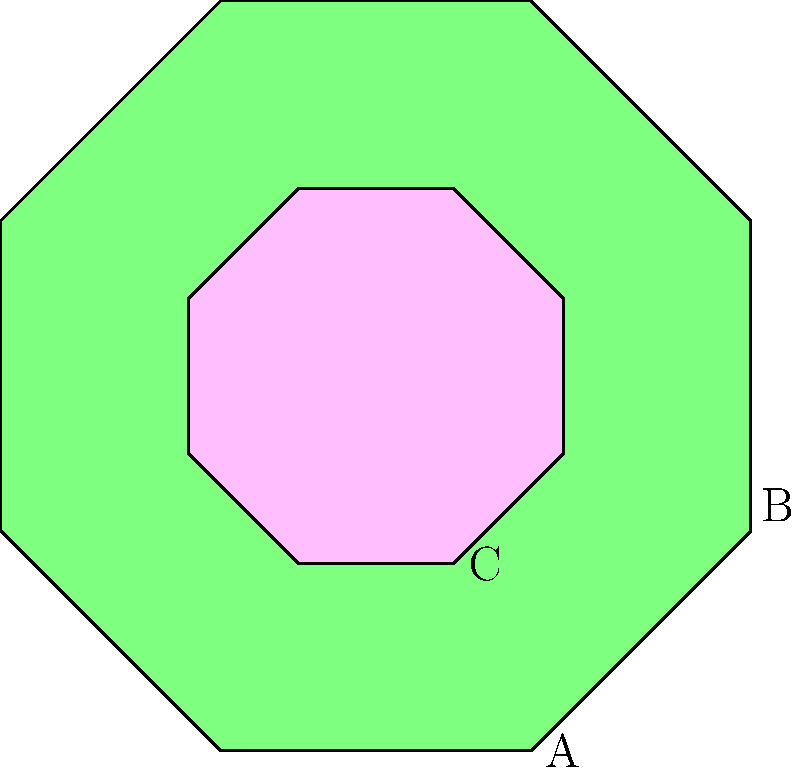In traditional Latvian folk art, geometric patterns often feature prominently. The diagram shows three regular octagons A, B, and C. Which of these octagons are congruent to each other? To determine which octagons are congruent, we need to examine their properties:

1. Octagon A: This is the largest octagon in the diagram, colored light blue.
2. Octagon B: This octagon is the same size as A but rotated 45 degrees, colored light green.
3. Octagon C: This is the smallest octagon, colored pink.

For polygons to be congruent, they must have:
- The same number of sides (which all do, as they are all octagons)
- The same side lengths
- The same interior angles

Step 1: Compare A and B
- A and B appear to be the same size
- B is rotated 45 degrees compared to A
- Rotation does not affect congruence

Step 2: Compare A and C
- C is visibly smaller than A
- Different sizes mean they cannot be congruent

Step 3: Compare B and C
- C is visibly smaller than B
- Different sizes mean they cannot be congruent

Conclusion: Only octagons A and B are congruent to each other. Octagon C is not congruent to either A or B due to its smaller size.
Answer: A and B 